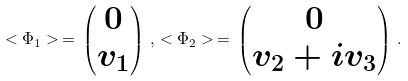<formula> <loc_0><loc_0><loc_500><loc_500>< \Phi _ { 1 } > \, = \, \begin{pmatrix} 0 \\ v _ { 1 } \end{pmatrix} \, , \, < \Phi _ { 2 } > \, = \, \begin{pmatrix} 0 \\ v _ { 2 } + i v _ { 3 } \end{pmatrix} \, .</formula> 